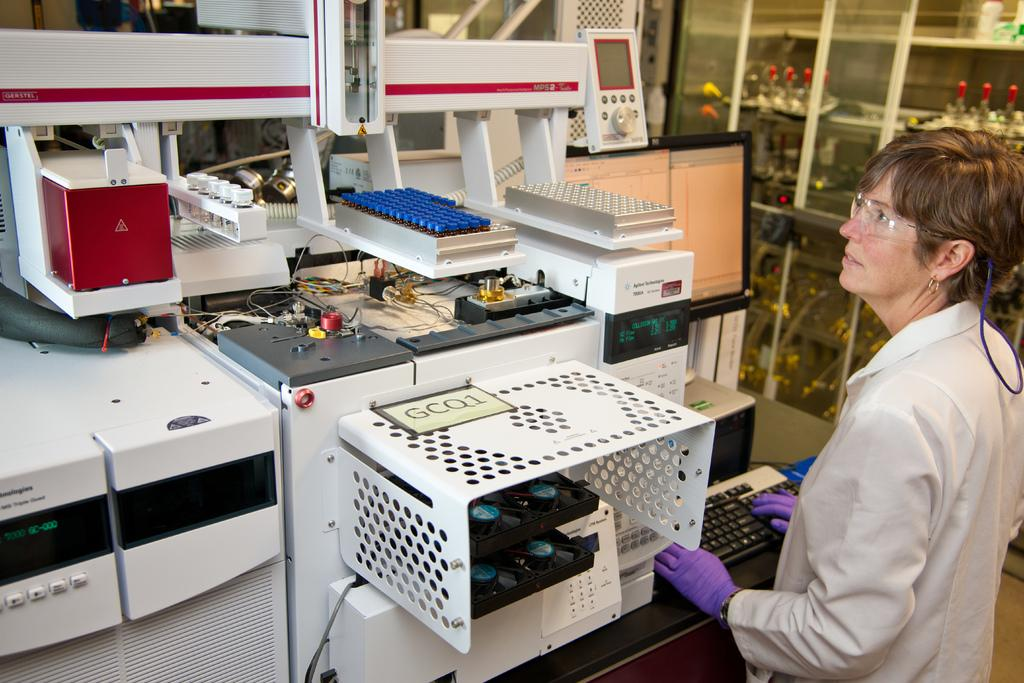Who is present on the right side of the image? There is a lady standing on the right side of the image. What is the lady wearing? The lady is wearing an apron. What can be seen in the image besides the lady? A keyboard and machines are visible in the image. Where is the door located in the image? There is a door on the right side of the image. What type of breakfast is being prepared on the keyboard in the image? There is no breakfast or preparation of food visible on the keyboard in the image. 